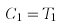<formula> <loc_0><loc_0><loc_500><loc_500>C _ { 1 } = T _ { 1 }</formula> 